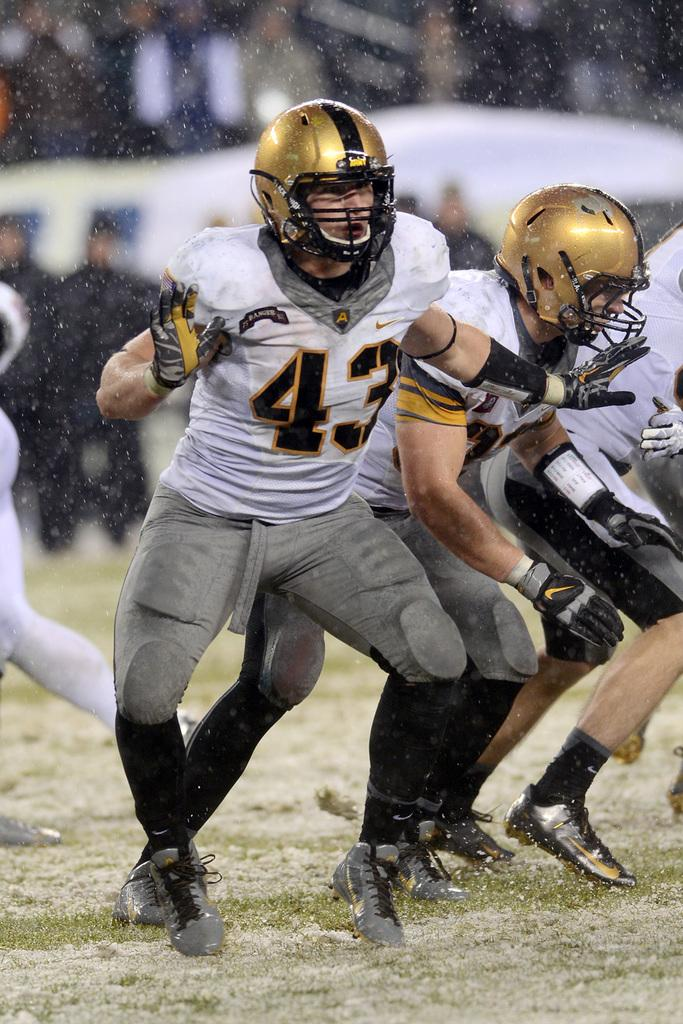How many people are in the image? There is a group of people in the image. What is the position of the people in the image? The people are standing on the ground. What are the people wearing on their heads? The people are wearing helmets. Can you describe the background of the image? There are additional people visible in the background of the image. What type of drain is visible in the wilderness area of the image? There is no drain or wilderness area present in the image. 